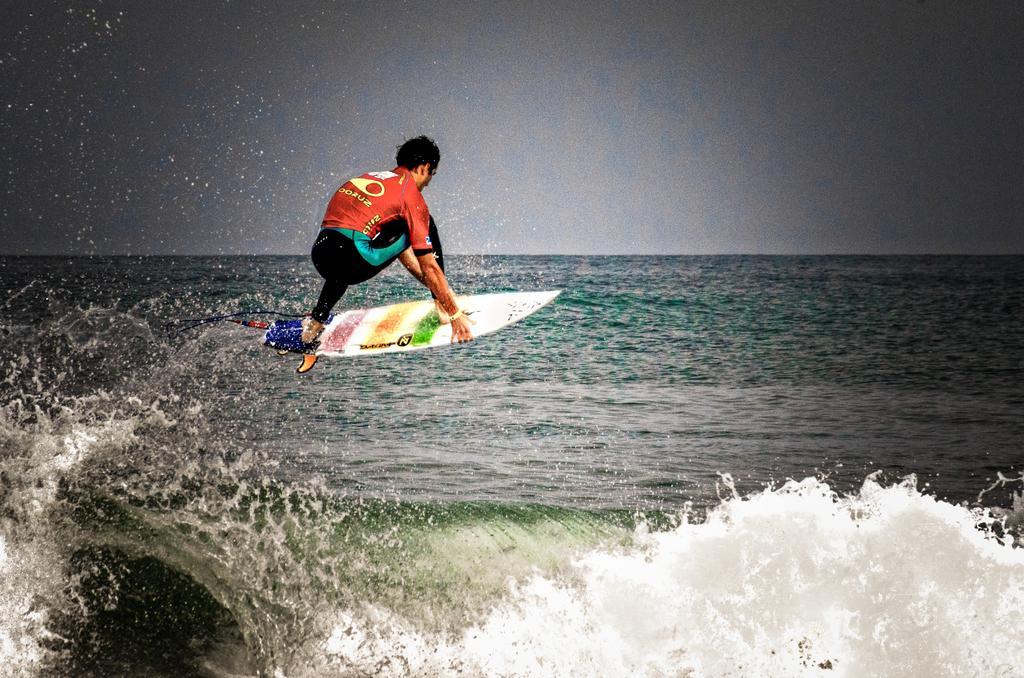Can you describe this image briefly? In this image, we can see a person on the waterboard, we can see water, at the top we can see the sky. 